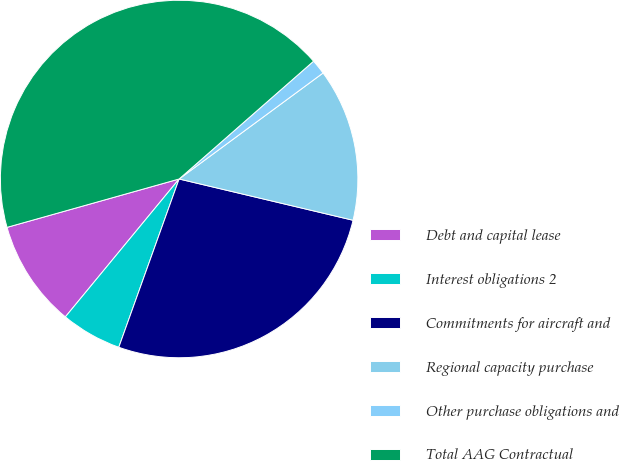<chart> <loc_0><loc_0><loc_500><loc_500><pie_chart><fcel>Debt and capital lease<fcel>Interest obligations 2<fcel>Commitments for aircraft and<fcel>Regional capacity purchase<fcel>Other purchase obligations and<fcel>Total AAG Contractual<nl><fcel>9.66%<fcel>5.5%<fcel>26.77%<fcel>13.81%<fcel>1.35%<fcel>42.91%<nl></chart> 